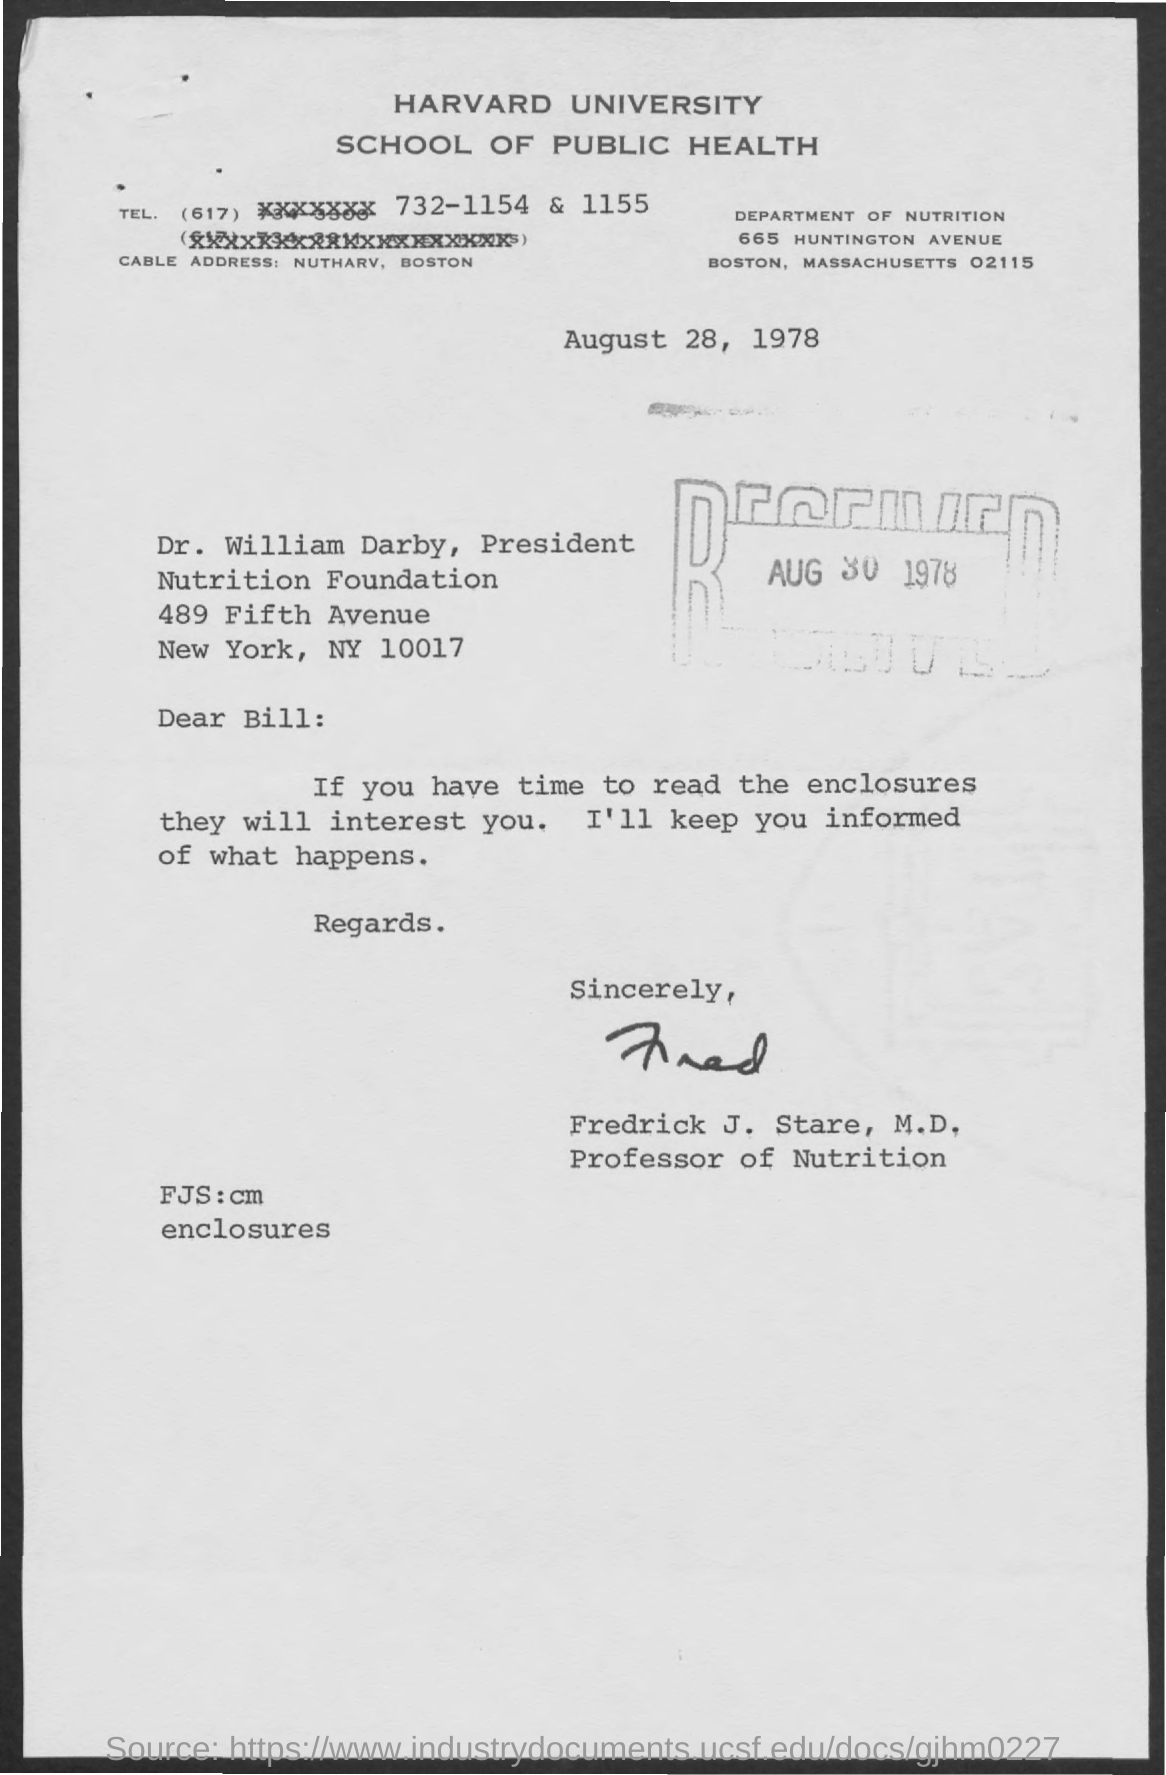What is the name of the university mentioned ?
Your response must be concise. Harvard university. What  is the department mentioned ?
Keep it short and to the point. Department of nutrition. What is the date mentioned in the given page ?
Offer a very short reply. AUGUST 28, 1978. What is the received date mentioned ?
Your answer should be very brief. Aug 30 , 1978. What is the cable address mentioned ?
Keep it short and to the point. Nutharv, boston. What is the designation of dr. william darby ?
Keep it short and to the point. PRESIDENT. What is the designation of fredrick j stare mentioned ?
Your answer should be compact. PROFESSOR OF NUTRITION. 